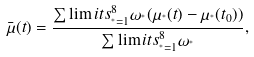Convert formula to latex. <formula><loc_0><loc_0><loc_500><loc_500>\bar { \mu } ( t ) = \frac { \sum \lim i t s _ { ^ { * } = 1 } ^ { 8 } \omega _ { ^ { * } } ( \mu _ { ^ { * } } ( t ) - \mu _ { ^ { * } } ( t _ { 0 } ) ) } { \sum \lim i t s _ { ^ { * } = 1 } ^ { 8 } \omega _ { ^ { * } } } ,</formula> 